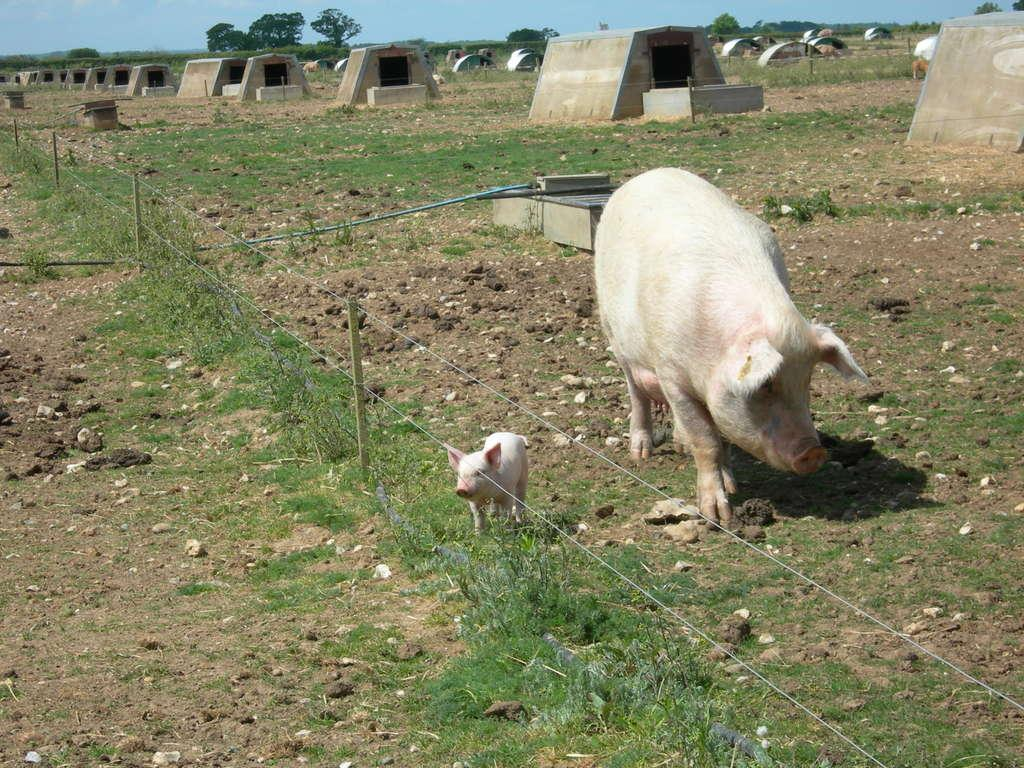How many pigs are present in the image? There are two pigs in the image. What color are the pigs? The pigs are white in color. What can be seen in the background of the image? There are trees and grass in the background of the image. What color are the trees and grass? The trees are green in color, and the grass is also green in color. What color is the sky in the image? The sky is blue in color. Where is the amusement park located in the image? There is no amusement park present in the image; it features two white pigs and a background with green trees, grass, and a blue sky. What type of basket is being used to hold the pigs in the image? There is no basket present in the image; it features two white pigs and a background with green trees, grass, and a blue sky. 